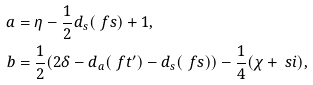<formula> <loc_0><loc_0><loc_500><loc_500>a & = \eta - \frac { 1 } { 2 } d _ { s } ( \ f s ) + 1 , \\ b & = \frac { 1 } { 2 } ( 2 \delta - d _ { a } ( \ f t ^ { \prime } ) - d _ { s } ( \ f s ) ) - \frac { 1 } { 4 } ( \chi + \ s i ) ,</formula> 